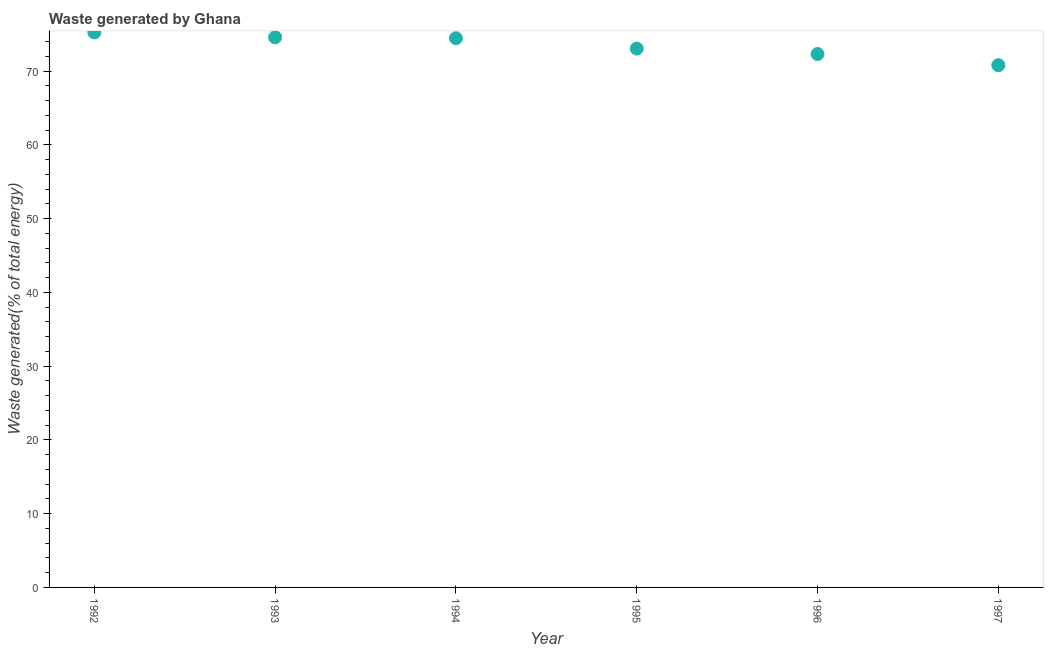What is the amount of waste generated in 1995?
Provide a succinct answer. 73.06. Across all years, what is the maximum amount of waste generated?
Your answer should be compact. 75.25. Across all years, what is the minimum amount of waste generated?
Your answer should be very brief. 70.81. In which year was the amount of waste generated minimum?
Provide a short and direct response. 1997. What is the sum of the amount of waste generated?
Make the answer very short. 440.52. What is the difference between the amount of waste generated in 1992 and 1996?
Your answer should be compact. 2.92. What is the average amount of waste generated per year?
Provide a succinct answer. 73.42. What is the median amount of waste generated?
Provide a succinct answer. 73.77. In how many years, is the amount of waste generated greater than 34 %?
Make the answer very short. 6. What is the ratio of the amount of waste generated in 1992 to that in 1996?
Give a very brief answer. 1.04. Is the difference between the amount of waste generated in 1992 and 1994 greater than the difference between any two years?
Offer a very short reply. No. What is the difference between the highest and the second highest amount of waste generated?
Keep it short and to the point. 0.66. Is the sum of the amount of waste generated in 1994 and 1996 greater than the maximum amount of waste generated across all years?
Make the answer very short. Yes. What is the difference between the highest and the lowest amount of waste generated?
Ensure brevity in your answer.  4.44. Does the amount of waste generated monotonically increase over the years?
Offer a terse response. No. How many years are there in the graph?
Keep it short and to the point. 6. What is the difference between two consecutive major ticks on the Y-axis?
Make the answer very short. 10. What is the title of the graph?
Provide a succinct answer. Waste generated by Ghana. What is the label or title of the Y-axis?
Ensure brevity in your answer.  Waste generated(% of total energy). What is the Waste generated(% of total energy) in 1992?
Offer a very short reply. 75.25. What is the Waste generated(% of total energy) in 1993?
Offer a very short reply. 74.59. What is the Waste generated(% of total energy) in 1994?
Give a very brief answer. 74.47. What is the Waste generated(% of total energy) in 1995?
Your answer should be compact. 73.06. What is the Waste generated(% of total energy) in 1996?
Give a very brief answer. 72.33. What is the Waste generated(% of total energy) in 1997?
Make the answer very short. 70.81. What is the difference between the Waste generated(% of total energy) in 1992 and 1993?
Offer a very short reply. 0.66. What is the difference between the Waste generated(% of total energy) in 1992 and 1994?
Provide a short and direct response. 0.79. What is the difference between the Waste generated(% of total energy) in 1992 and 1995?
Ensure brevity in your answer.  2.19. What is the difference between the Waste generated(% of total energy) in 1992 and 1996?
Give a very brief answer. 2.92. What is the difference between the Waste generated(% of total energy) in 1992 and 1997?
Give a very brief answer. 4.44. What is the difference between the Waste generated(% of total energy) in 1993 and 1994?
Give a very brief answer. 0.13. What is the difference between the Waste generated(% of total energy) in 1993 and 1995?
Ensure brevity in your answer.  1.53. What is the difference between the Waste generated(% of total energy) in 1993 and 1996?
Ensure brevity in your answer.  2.26. What is the difference between the Waste generated(% of total energy) in 1993 and 1997?
Make the answer very short. 3.78. What is the difference between the Waste generated(% of total energy) in 1994 and 1995?
Make the answer very short. 1.4. What is the difference between the Waste generated(% of total energy) in 1994 and 1996?
Your response must be concise. 2.14. What is the difference between the Waste generated(% of total energy) in 1994 and 1997?
Your answer should be very brief. 3.65. What is the difference between the Waste generated(% of total energy) in 1995 and 1996?
Make the answer very short. 0.73. What is the difference between the Waste generated(% of total energy) in 1995 and 1997?
Your answer should be very brief. 2.25. What is the difference between the Waste generated(% of total energy) in 1996 and 1997?
Keep it short and to the point. 1.52. What is the ratio of the Waste generated(% of total energy) in 1992 to that in 1993?
Ensure brevity in your answer.  1.01. What is the ratio of the Waste generated(% of total energy) in 1992 to that in 1995?
Provide a succinct answer. 1.03. What is the ratio of the Waste generated(% of total energy) in 1992 to that in 1997?
Your answer should be very brief. 1.06. What is the ratio of the Waste generated(% of total energy) in 1993 to that in 1996?
Your answer should be compact. 1.03. What is the ratio of the Waste generated(% of total energy) in 1993 to that in 1997?
Provide a succinct answer. 1.05. What is the ratio of the Waste generated(% of total energy) in 1994 to that in 1995?
Provide a short and direct response. 1.02. What is the ratio of the Waste generated(% of total energy) in 1994 to that in 1996?
Keep it short and to the point. 1.03. What is the ratio of the Waste generated(% of total energy) in 1994 to that in 1997?
Provide a succinct answer. 1.05. What is the ratio of the Waste generated(% of total energy) in 1995 to that in 1996?
Your answer should be very brief. 1.01. What is the ratio of the Waste generated(% of total energy) in 1995 to that in 1997?
Give a very brief answer. 1.03. What is the ratio of the Waste generated(% of total energy) in 1996 to that in 1997?
Offer a terse response. 1.02. 